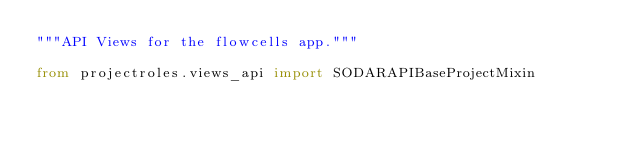<code> <loc_0><loc_0><loc_500><loc_500><_Python_>"""API Views for the flowcells app."""

from projectroles.views_api import SODARAPIBaseProjectMixin</code> 